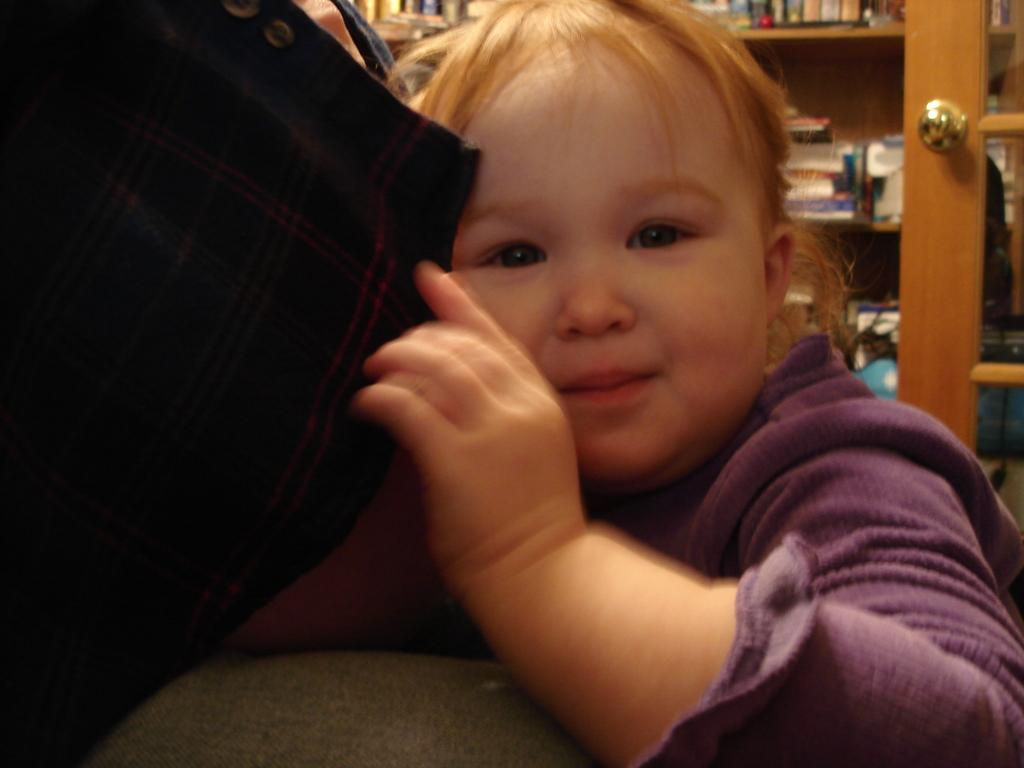What is the main subject of the image? The main subject of the image is a kid. What is the kid wearing? The kid is wearing a violet dress. What is the kid holding in the image? The kid is holding a shirt. What can be seen in the background of the image? There is a bookshelf in the background of the image. What type of glue can be seen on the sofa in the image? There is no sofa or glue present in the image. Where is the kid playing in the park in the image? The image does not show the kid playing in a park; it is set indoors with a bookshelf in the background. 